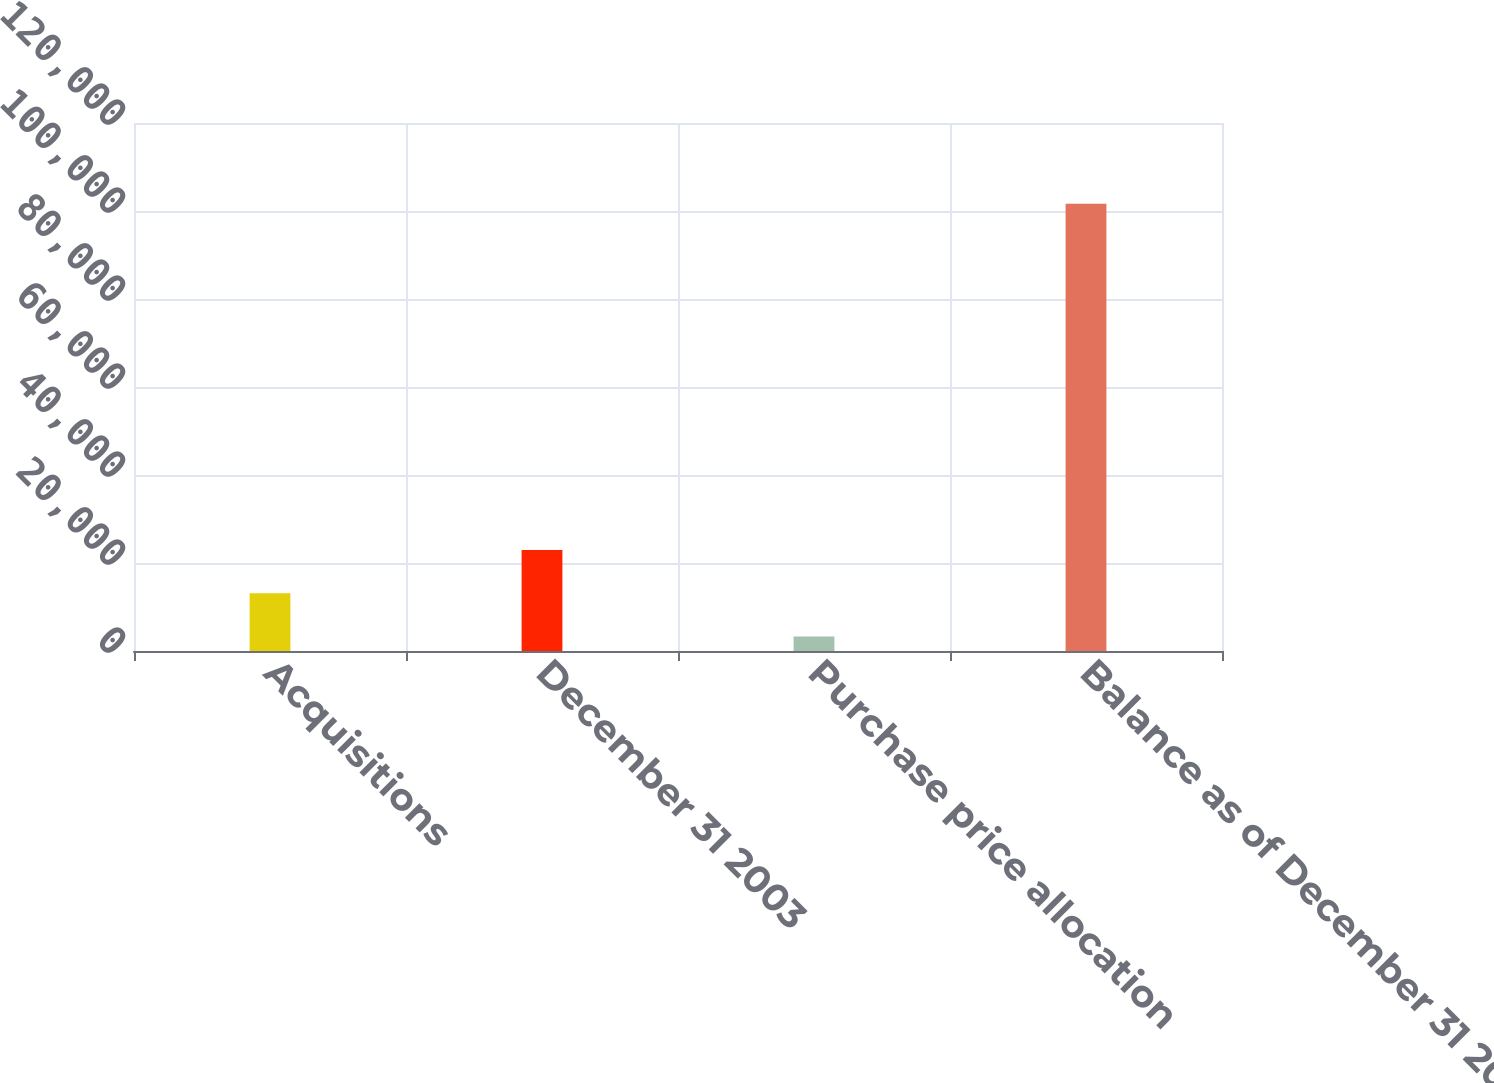Convert chart to OTSL. <chart><loc_0><loc_0><loc_500><loc_500><bar_chart><fcel>Acquisitions<fcel>December 31 2003<fcel>Purchase price allocation<fcel>Balance as of December 31 2004<nl><fcel>13128.6<fcel>22962.2<fcel>3295<fcel>101631<nl></chart> 